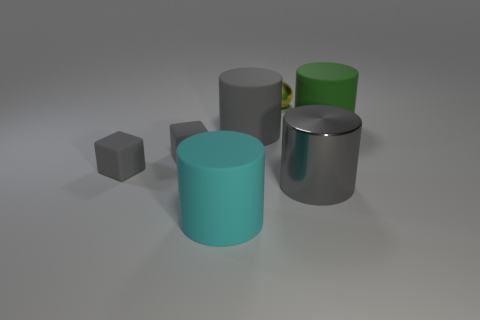Add 3 tiny gray blocks. How many objects exist? 10 Subtract all cylinders. How many objects are left? 3 Subtract 0 yellow cubes. How many objects are left? 7 Subtract all tiny gray metal cylinders. Subtract all rubber cylinders. How many objects are left? 4 Add 7 cubes. How many cubes are left? 9 Add 6 red cubes. How many red cubes exist? 6 